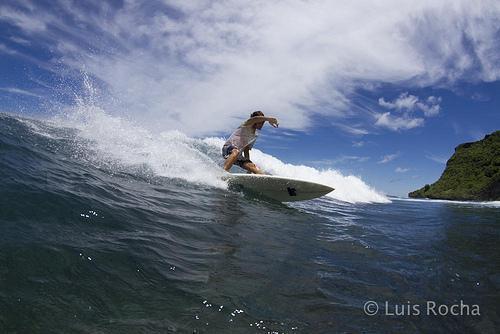How many people are in the picture?
Give a very brief answer. 1. 